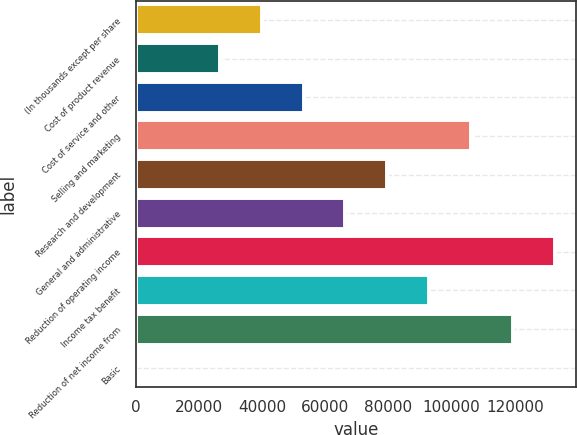Convert chart. <chart><loc_0><loc_0><loc_500><loc_500><bar_chart><fcel>(In thousands except per share<fcel>Cost of product revenue<fcel>Cost of service and other<fcel>Selling and marketing<fcel>Research and development<fcel>General and administrative<fcel>Reduction of operating income<fcel>Income tax benefit<fcel>Reduction of net income from<fcel>Basic<nl><fcel>39833.6<fcel>26555.8<fcel>53111.3<fcel>106222<fcel>79666.9<fcel>66389.1<fcel>132778<fcel>92944.6<fcel>119500<fcel>0.26<nl></chart> 